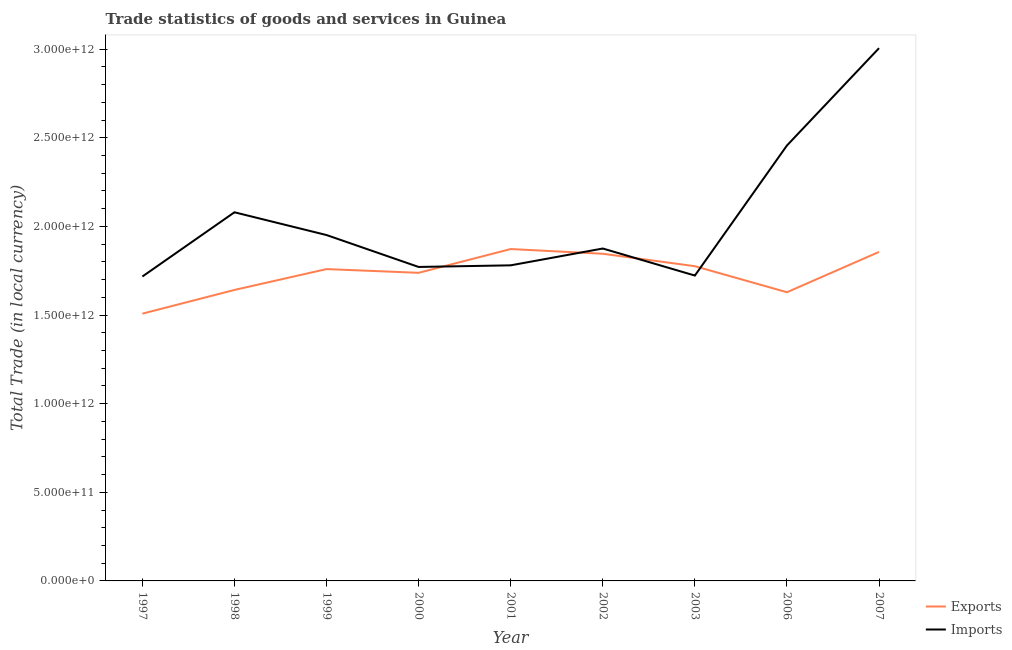How many different coloured lines are there?
Your answer should be very brief. 2. Does the line corresponding to export of goods and services intersect with the line corresponding to imports of goods and services?
Give a very brief answer. Yes. Is the number of lines equal to the number of legend labels?
Make the answer very short. Yes. What is the imports of goods and services in 1999?
Give a very brief answer. 1.95e+12. Across all years, what is the maximum export of goods and services?
Offer a very short reply. 1.87e+12. Across all years, what is the minimum imports of goods and services?
Provide a succinct answer. 1.72e+12. In which year was the imports of goods and services maximum?
Your answer should be compact. 2007. In which year was the imports of goods and services minimum?
Your answer should be very brief. 1997. What is the total export of goods and services in the graph?
Make the answer very short. 1.56e+13. What is the difference between the imports of goods and services in 1998 and that in 2002?
Your response must be concise. 2.04e+11. What is the difference between the imports of goods and services in 2003 and the export of goods and services in 2000?
Your answer should be very brief. -1.55e+1. What is the average export of goods and services per year?
Keep it short and to the point. 1.74e+12. In the year 2003, what is the difference between the imports of goods and services and export of goods and services?
Your answer should be very brief. -5.28e+1. What is the ratio of the imports of goods and services in 2002 to that in 2007?
Ensure brevity in your answer.  0.62. Is the difference between the imports of goods and services in 2000 and 2002 greater than the difference between the export of goods and services in 2000 and 2002?
Give a very brief answer. Yes. What is the difference between the highest and the second highest export of goods and services?
Offer a terse response. 1.62e+1. What is the difference between the highest and the lowest imports of goods and services?
Provide a short and direct response. 1.29e+12. In how many years, is the imports of goods and services greater than the average imports of goods and services taken over all years?
Offer a very short reply. 3. Does the export of goods and services monotonically increase over the years?
Offer a very short reply. No. How many lines are there?
Offer a terse response. 2. What is the difference between two consecutive major ticks on the Y-axis?
Your answer should be compact. 5.00e+11. Does the graph contain any zero values?
Offer a terse response. No. Where does the legend appear in the graph?
Give a very brief answer. Bottom right. How are the legend labels stacked?
Provide a succinct answer. Vertical. What is the title of the graph?
Your response must be concise. Trade statistics of goods and services in Guinea. What is the label or title of the X-axis?
Ensure brevity in your answer.  Year. What is the label or title of the Y-axis?
Provide a succinct answer. Total Trade (in local currency). What is the Total Trade (in local currency) in Exports in 1997?
Provide a short and direct response. 1.51e+12. What is the Total Trade (in local currency) of Imports in 1997?
Provide a short and direct response. 1.72e+12. What is the Total Trade (in local currency) of Exports in 1998?
Provide a succinct answer. 1.64e+12. What is the Total Trade (in local currency) of Imports in 1998?
Ensure brevity in your answer.  2.08e+12. What is the Total Trade (in local currency) of Exports in 1999?
Offer a terse response. 1.76e+12. What is the Total Trade (in local currency) of Imports in 1999?
Provide a short and direct response. 1.95e+12. What is the Total Trade (in local currency) of Exports in 2000?
Keep it short and to the point. 1.74e+12. What is the Total Trade (in local currency) of Imports in 2000?
Offer a very short reply. 1.77e+12. What is the Total Trade (in local currency) of Exports in 2001?
Your response must be concise. 1.87e+12. What is the Total Trade (in local currency) of Imports in 2001?
Offer a terse response. 1.78e+12. What is the Total Trade (in local currency) in Exports in 2002?
Your answer should be very brief. 1.85e+12. What is the Total Trade (in local currency) of Imports in 2002?
Keep it short and to the point. 1.88e+12. What is the Total Trade (in local currency) in Exports in 2003?
Provide a succinct answer. 1.78e+12. What is the Total Trade (in local currency) of Imports in 2003?
Your answer should be compact. 1.72e+12. What is the Total Trade (in local currency) in Exports in 2006?
Your answer should be compact. 1.63e+12. What is the Total Trade (in local currency) of Imports in 2006?
Ensure brevity in your answer.  2.46e+12. What is the Total Trade (in local currency) in Exports in 2007?
Your response must be concise. 1.86e+12. What is the Total Trade (in local currency) in Imports in 2007?
Keep it short and to the point. 3.01e+12. Across all years, what is the maximum Total Trade (in local currency) of Exports?
Keep it short and to the point. 1.87e+12. Across all years, what is the maximum Total Trade (in local currency) in Imports?
Your answer should be compact. 3.01e+12. Across all years, what is the minimum Total Trade (in local currency) in Exports?
Make the answer very short. 1.51e+12. Across all years, what is the minimum Total Trade (in local currency) in Imports?
Provide a short and direct response. 1.72e+12. What is the total Total Trade (in local currency) in Exports in the graph?
Your answer should be compact. 1.56e+13. What is the total Total Trade (in local currency) of Imports in the graph?
Provide a succinct answer. 1.84e+13. What is the difference between the Total Trade (in local currency) of Exports in 1997 and that in 1998?
Ensure brevity in your answer.  -1.34e+11. What is the difference between the Total Trade (in local currency) of Imports in 1997 and that in 1998?
Make the answer very short. -3.62e+11. What is the difference between the Total Trade (in local currency) in Exports in 1997 and that in 1999?
Keep it short and to the point. -2.51e+11. What is the difference between the Total Trade (in local currency) in Imports in 1997 and that in 1999?
Ensure brevity in your answer.  -2.34e+11. What is the difference between the Total Trade (in local currency) of Exports in 1997 and that in 2000?
Offer a terse response. -2.31e+11. What is the difference between the Total Trade (in local currency) of Imports in 1997 and that in 2000?
Make the answer very short. -5.39e+1. What is the difference between the Total Trade (in local currency) of Exports in 1997 and that in 2001?
Offer a terse response. -3.65e+11. What is the difference between the Total Trade (in local currency) in Imports in 1997 and that in 2001?
Make the answer very short. -6.32e+1. What is the difference between the Total Trade (in local currency) in Exports in 1997 and that in 2002?
Ensure brevity in your answer.  -3.38e+11. What is the difference between the Total Trade (in local currency) in Imports in 1997 and that in 2002?
Make the answer very short. -1.58e+11. What is the difference between the Total Trade (in local currency) in Exports in 1997 and that in 2003?
Offer a terse response. -2.68e+11. What is the difference between the Total Trade (in local currency) of Imports in 1997 and that in 2003?
Your answer should be very brief. -5.43e+09. What is the difference between the Total Trade (in local currency) of Exports in 1997 and that in 2006?
Give a very brief answer. -1.21e+11. What is the difference between the Total Trade (in local currency) of Imports in 1997 and that in 2006?
Provide a short and direct response. -7.39e+11. What is the difference between the Total Trade (in local currency) of Exports in 1997 and that in 2007?
Give a very brief answer. -3.48e+11. What is the difference between the Total Trade (in local currency) of Imports in 1997 and that in 2007?
Make the answer very short. -1.29e+12. What is the difference between the Total Trade (in local currency) in Exports in 1998 and that in 1999?
Offer a terse response. -1.18e+11. What is the difference between the Total Trade (in local currency) of Imports in 1998 and that in 1999?
Ensure brevity in your answer.  1.28e+11. What is the difference between the Total Trade (in local currency) of Exports in 1998 and that in 2000?
Give a very brief answer. -9.66e+1. What is the difference between the Total Trade (in local currency) in Imports in 1998 and that in 2000?
Provide a succinct answer. 3.08e+11. What is the difference between the Total Trade (in local currency) of Exports in 1998 and that in 2001?
Your answer should be very brief. -2.31e+11. What is the difference between the Total Trade (in local currency) in Imports in 1998 and that in 2001?
Provide a succinct answer. 2.99e+11. What is the difference between the Total Trade (in local currency) in Exports in 1998 and that in 2002?
Provide a short and direct response. -2.04e+11. What is the difference between the Total Trade (in local currency) of Imports in 1998 and that in 2002?
Your answer should be compact. 2.04e+11. What is the difference between the Total Trade (in local currency) in Exports in 1998 and that in 2003?
Ensure brevity in your answer.  -1.34e+11. What is the difference between the Total Trade (in local currency) of Imports in 1998 and that in 2003?
Offer a terse response. 3.57e+11. What is the difference between the Total Trade (in local currency) of Exports in 1998 and that in 2006?
Ensure brevity in your answer.  1.30e+1. What is the difference between the Total Trade (in local currency) in Imports in 1998 and that in 2006?
Your response must be concise. -3.77e+11. What is the difference between the Total Trade (in local currency) of Exports in 1998 and that in 2007?
Give a very brief answer. -2.15e+11. What is the difference between the Total Trade (in local currency) of Imports in 1998 and that in 2007?
Offer a terse response. -9.26e+11. What is the difference between the Total Trade (in local currency) of Exports in 1999 and that in 2000?
Offer a terse response. 2.10e+1. What is the difference between the Total Trade (in local currency) of Imports in 1999 and that in 2000?
Offer a terse response. 1.80e+11. What is the difference between the Total Trade (in local currency) of Exports in 1999 and that in 2001?
Provide a succinct answer. -1.13e+11. What is the difference between the Total Trade (in local currency) in Imports in 1999 and that in 2001?
Your response must be concise. 1.71e+11. What is the difference between the Total Trade (in local currency) in Exports in 1999 and that in 2002?
Ensure brevity in your answer.  -8.65e+1. What is the difference between the Total Trade (in local currency) in Imports in 1999 and that in 2002?
Your response must be concise. 7.60e+1. What is the difference between the Total Trade (in local currency) of Exports in 1999 and that in 2003?
Provide a succinct answer. -1.63e+1. What is the difference between the Total Trade (in local currency) of Imports in 1999 and that in 2003?
Keep it short and to the point. 2.29e+11. What is the difference between the Total Trade (in local currency) in Exports in 1999 and that in 2006?
Provide a succinct answer. 1.31e+11. What is the difference between the Total Trade (in local currency) in Imports in 1999 and that in 2006?
Your answer should be very brief. -5.05e+11. What is the difference between the Total Trade (in local currency) in Exports in 1999 and that in 2007?
Keep it short and to the point. -9.69e+1. What is the difference between the Total Trade (in local currency) in Imports in 1999 and that in 2007?
Provide a succinct answer. -1.05e+12. What is the difference between the Total Trade (in local currency) of Exports in 2000 and that in 2001?
Offer a terse response. -1.34e+11. What is the difference between the Total Trade (in local currency) of Imports in 2000 and that in 2001?
Provide a succinct answer. -9.21e+09. What is the difference between the Total Trade (in local currency) of Exports in 2000 and that in 2002?
Keep it short and to the point. -1.07e+11. What is the difference between the Total Trade (in local currency) in Imports in 2000 and that in 2002?
Keep it short and to the point. -1.04e+11. What is the difference between the Total Trade (in local currency) in Exports in 2000 and that in 2003?
Provide a succinct answer. -3.73e+1. What is the difference between the Total Trade (in local currency) in Imports in 2000 and that in 2003?
Ensure brevity in your answer.  4.85e+1. What is the difference between the Total Trade (in local currency) in Exports in 2000 and that in 2006?
Offer a very short reply. 1.10e+11. What is the difference between the Total Trade (in local currency) of Imports in 2000 and that in 2006?
Your answer should be compact. -6.85e+11. What is the difference between the Total Trade (in local currency) of Exports in 2000 and that in 2007?
Make the answer very short. -1.18e+11. What is the difference between the Total Trade (in local currency) of Imports in 2000 and that in 2007?
Your response must be concise. -1.23e+12. What is the difference between the Total Trade (in local currency) of Exports in 2001 and that in 2002?
Your answer should be very brief. 2.67e+1. What is the difference between the Total Trade (in local currency) of Imports in 2001 and that in 2002?
Your answer should be compact. -9.49e+1. What is the difference between the Total Trade (in local currency) of Exports in 2001 and that in 2003?
Provide a short and direct response. 9.68e+1. What is the difference between the Total Trade (in local currency) in Imports in 2001 and that in 2003?
Offer a very short reply. 5.77e+1. What is the difference between the Total Trade (in local currency) in Exports in 2001 and that in 2006?
Ensure brevity in your answer.  2.44e+11. What is the difference between the Total Trade (in local currency) in Imports in 2001 and that in 2006?
Your answer should be compact. -6.76e+11. What is the difference between the Total Trade (in local currency) in Exports in 2001 and that in 2007?
Give a very brief answer. 1.62e+1. What is the difference between the Total Trade (in local currency) in Imports in 2001 and that in 2007?
Ensure brevity in your answer.  -1.23e+12. What is the difference between the Total Trade (in local currency) of Exports in 2002 and that in 2003?
Keep it short and to the point. 7.02e+1. What is the difference between the Total Trade (in local currency) of Imports in 2002 and that in 2003?
Keep it short and to the point. 1.53e+11. What is the difference between the Total Trade (in local currency) of Exports in 2002 and that in 2006?
Offer a very short reply. 2.17e+11. What is the difference between the Total Trade (in local currency) of Imports in 2002 and that in 2006?
Your answer should be compact. -5.81e+11. What is the difference between the Total Trade (in local currency) of Exports in 2002 and that in 2007?
Your response must be concise. -1.04e+1. What is the difference between the Total Trade (in local currency) of Imports in 2002 and that in 2007?
Offer a terse response. -1.13e+12. What is the difference between the Total Trade (in local currency) of Exports in 2003 and that in 2006?
Keep it short and to the point. 1.47e+11. What is the difference between the Total Trade (in local currency) in Imports in 2003 and that in 2006?
Make the answer very short. -7.34e+11. What is the difference between the Total Trade (in local currency) of Exports in 2003 and that in 2007?
Your response must be concise. -8.06e+1. What is the difference between the Total Trade (in local currency) of Imports in 2003 and that in 2007?
Offer a very short reply. -1.28e+12. What is the difference between the Total Trade (in local currency) of Exports in 2006 and that in 2007?
Provide a succinct answer. -2.27e+11. What is the difference between the Total Trade (in local currency) in Imports in 2006 and that in 2007?
Give a very brief answer. -5.49e+11. What is the difference between the Total Trade (in local currency) of Exports in 1997 and the Total Trade (in local currency) of Imports in 1998?
Your answer should be compact. -5.72e+11. What is the difference between the Total Trade (in local currency) in Exports in 1997 and the Total Trade (in local currency) in Imports in 1999?
Provide a succinct answer. -4.44e+11. What is the difference between the Total Trade (in local currency) of Exports in 1997 and the Total Trade (in local currency) of Imports in 2000?
Offer a very short reply. -2.64e+11. What is the difference between the Total Trade (in local currency) of Exports in 1997 and the Total Trade (in local currency) of Imports in 2001?
Your response must be concise. -2.73e+11. What is the difference between the Total Trade (in local currency) in Exports in 1997 and the Total Trade (in local currency) in Imports in 2002?
Make the answer very short. -3.68e+11. What is the difference between the Total Trade (in local currency) of Exports in 1997 and the Total Trade (in local currency) of Imports in 2003?
Your response must be concise. -2.15e+11. What is the difference between the Total Trade (in local currency) of Exports in 1997 and the Total Trade (in local currency) of Imports in 2006?
Ensure brevity in your answer.  -9.49e+11. What is the difference between the Total Trade (in local currency) of Exports in 1997 and the Total Trade (in local currency) of Imports in 2007?
Provide a short and direct response. -1.50e+12. What is the difference between the Total Trade (in local currency) of Exports in 1998 and the Total Trade (in local currency) of Imports in 1999?
Keep it short and to the point. -3.10e+11. What is the difference between the Total Trade (in local currency) in Exports in 1998 and the Total Trade (in local currency) in Imports in 2000?
Offer a very short reply. -1.30e+11. What is the difference between the Total Trade (in local currency) in Exports in 1998 and the Total Trade (in local currency) in Imports in 2001?
Your response must be concise. -1.39e+11. What is the difference between the Total Trade (in local currency) of Exports in 1998 and the Total Trade (in local currency) of Imports in 2002?
Keep it short and to the point. -2.34e+11. What is the difference between the Total Trade (in local currency) in Exports in 1998 and the Total Trade (in local currency) in Imports in 2003?
Offer a terse response. -8.11e+1. What is the difference between the Total Trade (in local currency) of Exports in 1998 and the Total Trade (in local currency) of Imports in 2006?
Your answer should be compact. -8.15e+11. What is the difference between the Total Trade (in local currency) in Exports in 1998 and the Total Trade (in local currency) in Imports in 2007?
Your response must be concise. -1.36e+12. What is the difference between the Total Trade (in local currency) of Exports in 1999 and the Total Trade (in local currency) of Imports in 2000?
Keep it short and to the point. -1.20e+1. What is the difference between the Total Trade (in local currency) in Exports in 1999 and the Total Trade (in local currency) in Imports in 2001?
Offer a very short reply. -2.13e+1. What is the difference between the Total Trade (in local currency) in Exports in 1999 and the Total Trade (in local currency) in Imports in 2002?
Offer a terse response. -1.16e+11. What is the difference between the Total Trade (in local currency) of Exports in 1999 and the Total Trade (in local currency) of Imports in 2003?
Offer a terse response. 3.65e+1. What is the difference between the Total Trade (in local currency) of Exports in 1999 and the Total Trade (in local currency) of Imports in 2006?
Your answer should be very brief. -6.97e+11. What is the difference between the Total Trade (in local currency) of Exports in 1999 and the Total Trade (in local currency) of Imports in 2007?
Provide a short and direct response. -1.25e+12. What is the difference between the Total Trade (in local currency) of Exports in 2000 and the Total Trade (in local currency) of Imports in 2001?
Offer a very short reply. -4.22e+1. What is the difference between the Total Trade (in local currency) in Exports in 2000 and the Total Trade (in local currency) in Imports in 2002?
Keep it short and to the point. -1.37e+11. What is the difference between the Total Trade (in local currency) in Exports in 2000 and the Total Trade (in local currency) in Imports in 2003?
Provide a short and direct response. 1.55e+1. What is the difference between the Total Trade (in local currency) in Exports in 2000 and the Total Trade (in local currency) in Imports in 2006?
Give a very brief answer. -7.18e+11. What is the difference between the Total Trade (in local currency) in Exports in 2000 and the Total Trade (in local currency) in Imports in 2007?
Provide a succinct answer. -1.27e+12. What is the difference between the Total Trade (in local currency) in Exports in 2001 and the Total Trade (in local currency) in Imports in 2002?
Offer a terse response. -2.98e+09. What is the difference between the Total Trade (in local currency) in Exports in 2001 and the Total Trade (in local currency) in Imports in 2003?
Ensure brevity in your answer.  1.50e+11. What is the difference between the Total Trade (in local currency) in Exports in 2001 and the Total Trade (in local currency) in Imports in 2006?
Keep it short and to the point. -5.84e+11. What is the difference between the Total Trade (in local currency) of Exports in 2001 and the Total Trade (in local currency) of Imports in 2007?
Keep it short and to the point. -1.13e+12. What is the difference between the Total Trade (in local currency) in Exports in 2002 and the Total Trade (in local currency) in Imports in 2003?
Offer a very short reply. 1.23e+11. What is the difference between the Total Trade (in local currency) of Exports in 2002 and the Total Trade (in local currency) of Imports in 2006?
Keep it short and to the point. -6.11e+11. What is the difference between the Total Trade (in local currency) of Exports in 2002 and the Total Trade (in local currency) of Imports in 2007?
Your response must be concise. -1.16e+12. What is the difference between the Total Trade (in local currency) of Exports in 2003 and the Total Trade (in local currency) of Imports in 2006?
Offer a terse response. -6.81e+11. What is the difference between the Total Trade (in local currency) in Exports in 2003 and the Total Trade (in local currency) in Imports in 2007?
Keep it short and to the point. -1.23e+12. What is the difference between the Total Trade (in local currency) in Exports in 2006 and the Total Trade (in local currency) in Imports in 2007?
Give a very brief answer. -1.38e+12. What is the average Total Trade (in local currency) of Exports per year?
Provide a succinct answer. 1.74e+12. What is the average Total Trade (in local currency) in Imports per year?
Make the answer very short. 2.04e+12. In the year 1997, what is the difference between the Total Trade (in local currency) of Exports and Total Trade (in local currency) of Imports?
Your answer should be very brief. -2.10e+11. In the year 1998, what is the difference between the Total Trade (in local currency) of Exports and Total Trade (in local currency) of Imports?
Provide a succinct answer. -4.38e+11. In the year 1999, what is the difference between the Total Trade (in local currency) in Exports and Total Trade (in local currency) in Imports?
Give a very brief answer. -1.92e+11. In the year 2000, what is the difference between the Total Trade (in local currency) of Exports and Total Trade (in local currency) of Imports?
Ensure brevity in your answer.  -3.30e+1. In the year 2001, what is the difference between the Total Trade (in local currency) of Exports and Total Trade (in local currency) of Imports?
Make the answer very short. 9.19e+1. In the year 2002, what is the difference between the Total Trade (in local currency) in Exports and Total Trade (in local currency) in Imports?
Keep it short and to the point. -2.96e+1. In the year 2003, what is the difference between the Total Trade (in local currency) in Exports and Total Trade (in local currency) in Imports?
Make the answer very short. 5.28e+1. In the year 2006, what is the difference between the Total Trade (in local currency) of Exports and Total Trade (in local currency) of Imports?
Make the answer very short. -8.28e+11. In the year 2007, what is the difference between the Total Trade (in local currency) in Exports and Total Trade (in local currency) in Imports?
Provide a succinct answer. -1.15e+12. What is the ratio of the Total Trade (in local currency) of Exports in 1997 to that in 1998?
Give a very brief answer. 0.92. What is the ratio of the Total Trade (in local currency) in Imports in 1997 to that in 1998?
Make the answer very short. 0.83. What is the ratio of the Total Trade (in local currency) of Imports in 1997 to that in 1999?
Your response must be concise. 0.88. What is the ratio of the Total Trade (in local currency) in Exports in 1997 to that in 2000?
Provide a short and direct response. 0.87. What is the ratio of the Total Trade (in local currency) of Imports in 1997 to that in 2000?
Your answer should be very brief. 0.97. What is the ratio of the Total Trade (in local currency) of Exports in 1997 to that in 2001?
Offer a very short reply. 0.81. What is the ratio of the Total Trade (in local currency) in Imports in 1997 to that in 2001?
Offer a terse response. 0.96. What is the ratio of the Total Trade (in local currency) in Exports in 1997 to that in 2002?
Keep it short and to the point. 0.82. What is the ratio of the Total Trade (in local currency) of Imports in 1997 to that in 2002?
Give a very brief answer. 0.92. What is the ratio of the Total Trade (in local currency) of Exports in 1997 to that in 2003?
Your answer should be very brief. 0.85. What is the ratio of the Total Trade (in local currency) of Exports in 1997 to that in 2006?
Your response must be concise. 0.93. What is the ratio of the Total Trade (in local currency) in Imports in 1997 to that in 2006?
Your answer should be very brief. 0.7. What is the ratio of the Total Trade (in local currency) of Exports in 1997 to that in 2007?
Give a very brief answer. 0.81. What is the ratio of the Total Trade (in local currency) in Imports in 1997 to that in 2007?
Provide a succinct answer. 0.57. What is the ratio of the Total Trade (in local currency) in Exports in 1998 to that in 1999?
Offer a very short reply. 0.93. What is the ratio of the Total Trade (in local currency) of Imports in 1998 to that in 1999?
Provide a succinct answer. 1.07. What is the ratio of the Total Trade (in local currency) of Imports in 1998 to that in 2000?
Offer a terse response. 1.17. What is the ratio of the Total Trade (in local currency) of Exports in 1998 to that in 2001?
Provide a succinct answer. 0.88. What is the ratio of the Total Trade (in local currency) of Imports in 1998 to that in 2001?
Offer a terse response. 1.17. What is the ratio of the Total Trade (in local currency) of Exports in 1998 to that in 2002?
Provide a short and direct response. 0.89. What is the ratio of the Total Trade (in local currency) of Imports in 1998 to that in 2002?
Your answer should be very brief. 1.11. What is the ratio of the Total Trade (in local currency) of Exports in 1998 to that in 2003?
Give a very brief answer. 0.92. What is the ratio of the Total Trade (in local currency) of Imports in 1998 to that in 2003?
Provide a short and direct response. 1.21. What is the ratio of the Total Trade (in local currency) in Exports in 1998 to that in 2006?
Offer a very short reply. 1.01. What is the ratio of the Total Trade (in local currency) in Imports in 1998 to that in 2006?
Offer a terse response. 0.85. What is the ratio of the Total Trade (in local currency) of Exports in 1998 to that in 2007?
Your answer should be very brief. 0.88. What is the ratio of the Total Trade (in local currency) in Imports in 1998 to that in 2007?
Offer a terse response. 0.69. What is the ratio of the Total Trade (in local currency) in Exports in 1999 to that in 2000?
Provide a succinct answer. 1.01. What is the ratio of the Total Trade (in local currency) of Imports in 1999 to that in 2000?
Ensure brevity in your answer.  1.1. What is the ratio of the Total Trade (in local currency) of Exports in 1999 to that in 2001?
Offer a very short reply. 0.94. What is the ratio of the Total Trade (in local currency) of Imports in 1999 to that in 2001?
Offer a very short reply. 1.1. What is the ratio of the Total Trade (in local currency) in Exports in 1999 to that in 2002?
Keep it short and to the point. 0.95. What is the ratio of the Total Trade (in local currency) in Imports in 1999 to that in 2002?
Provide a succinct answer. 1.04. What is the ratio of the Total Trade (in local currency) of Imports in 1999 to that in 2003?
Your answer should be compact. 1.13. What is the ratio of the Total Trade (in local currency) of Exports in 1999 to that in 2006?
Keep it short and to the point. 1.08. What is the ratio of the Total Trade (in local currency) in Imports in 1999 to that in 2006?
Make the answer very short. 0.79. What is the ratio of the Total Trade (in local currency) in Exports in 1999 to that in 2007?
Keep it short and to the point. 0.95. What is the ratio of the Total Trade (in local currency) of Imports in 1999 to that in 2007?
Give a very brief answer. 0.65. What is the ratio of the Total Trade (in local currency) in Exports in 2000 to that in 2001?
Ensure brevity in your answer.  0.93. What is the ratio of the Total Trade (in local currency) in Imports in 2000 to that in 2001?
Give a very brief answer. 0.99. What is the ratio of the Total Trade (in local currency) in Exports in 2000 to that in 2002?
Your answer should be very brief. 0.94. What is the ratio of the Total Trade (in local currency) in Imports in 2000 to that in 2002?
Your answer should be very brief. 0.94. What is the ratio of the Total Trade (in local currency) in Exports in 2000 to that in 2003?
Your response must be concise. 0.98. What is the ratio of the Total Trade (in local currency) of Imports in 2000 to that in 2003?
Make the answer very short. 1.03. What is the ratio of the Total Trade (in local currency) of Exports in 2000 to that in 2006?
Ensure brevity in your answer.  1.07. What is the ratio of the Total Trade (in local currency) of Imports in 2000 to that in 2006?
Provide a succinct answer. 0.72. What is the ratio of the Total Trade (in local currency) of Exports in 2000 to that in 2007?
Give a very brief answer. 0.94. What is the ratio of the Total Trade (in local currency) in Imports in 2000 to that in 2007?
Make the answer very short. 0.59. What is the ratio of the Total Trade (in local currency) of Exports in 2001 to that in 2002?
Make the answer very short. 1.01. What is the ratio of the Total Trade (in local currency) of Imports in 2001 to that in 2002?
Ensure brevity in your answer.  0.95. What is the ratio of the Total Trade (in local currency) in Exports in 2001 to that in 2003?
Provide a short and direct response. 1.05. What is the ratio of the Total Trade (in local currency) in Imports in 2001 to that in 2003?
Provide a succinct answer. 1.03. What is the ratio of the Total Trade (in local currency) of Exports in 2001 to that in 2006?
Your response must be concise. 1.15. What is the ratio of the Total Trade (in local currency) of Imports in 2001 to that in 2006?
Offer a very short reply. 0.72. What is the ratio of the Total Trade (in local currency) of Exports in 2001 to that in 2007?
Your answer should be compact. 1.01. What is the ratio of the Total Trade (in local currency) in Imports in 2001 to that in 2007?
Provide a short and direct response. 0.59. What is the ratio of the Total Trade (in local currency) in Exports in 2002 to that in 2003?
Keep it short and to the point. 1.04. What is the ratio of the Total Trade (in local currency) of Imports in 2002 to that in 2003?
Provide a succinct answer. 1.09. What is the ratio of the Total Trade (in local currency) of Exports in 2002 to that in 2006?
Offer a very short reply. 1.13. What is the ratio of the Total Trade (in local currency) in Imports in 2002 to that in 2006?
Provide a succinct answer. 0.76. What is the ratio of the Total Trade (in local currency) in Exports in 2002 to that in 2007?
Your answer should be compact. 0.99. What is the ratio of the Total Trade (in local currency) of Imports in 2002 to that in 2007?
Your response must be concise. 0.62. What is the ratio of the Total Trade (in local currency) of Exports in 2003 to that in 2006?
Offer a very short reply. 1.09. What is the ratio of the Total Trade (in local currency) of Imports in 2003 to that in 2006?
Keep it short and to the point. 0.7. What is the ratio of the Total Trade (in local currency) in Exports in 2003 to that in 2007?
Offer a terse response. 0.96. What is the ratio of the Total Trade (in local currency) in Imports in 2003 to that in 2007?
Offer a very short reply. 0.57. What is the ratio of the Total Trade (in local currency) in Exports in 2006 to that in 2007?
Keep it short and to the point. 0.88. What is the ratio of the Total Trade (in local currency) in Imports in 2006 to that in 2007?
Ensure brevity in your answer.  0.82. What is the difference between the highest and the second highest Total Trade (in local currency) in Exports?
Your answer should be very brief. 1.62e+1. What is the difference between the highest and the second highest Total Trade (in local currency) of Imports?
Keep it short and to the point. 5.49e+11. What is the difference between the highest and the lowest Total Trade (in local currency) of Exports?
Your answer should be very brief. 3.65e+11. What is the difference between the highest and the lowest Total Trade (in local currency) in Imports?
Ensure brevity in your answer.  1.29e+12. 